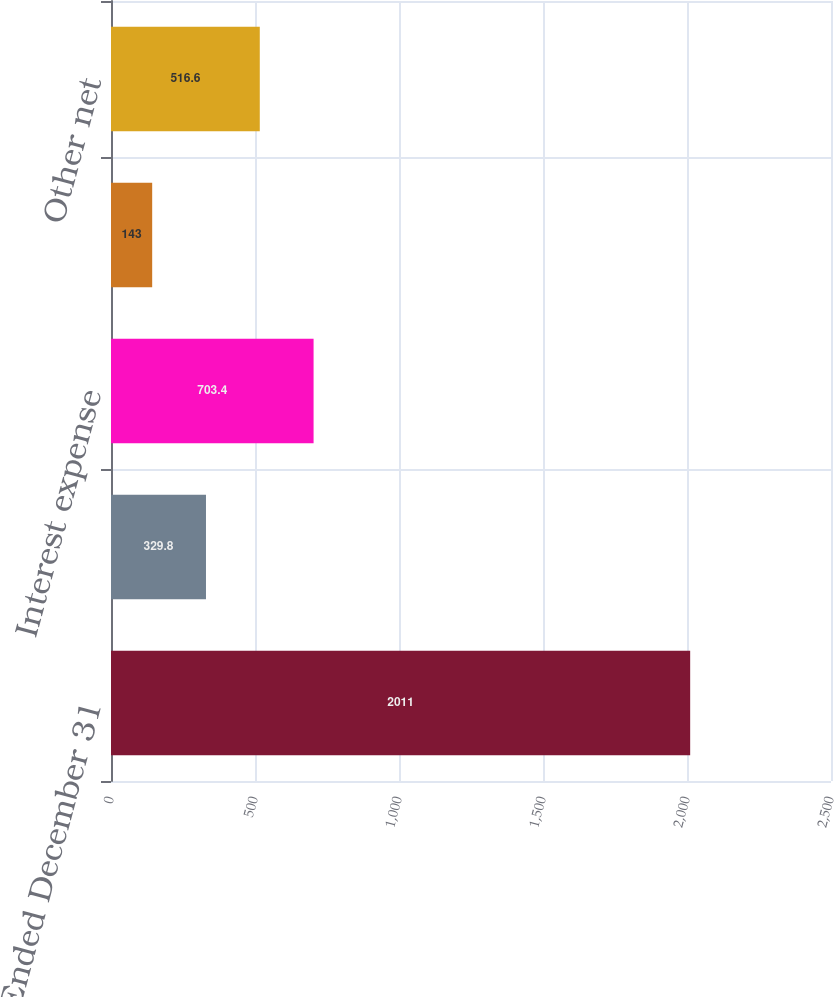Convert chart to OTSL. <chart><loc_0><loc_0><loc_500><loc_500><bar_chart><fcel>Years Ended December 31<fcel>Interest income<fcel>Interest expense<fcel>Exchange losses<fcel>Other net<nl><fcel>2011<fcel>329.8<fcel>703.4<fcel>143<fcel>516.6<nl></chart> 